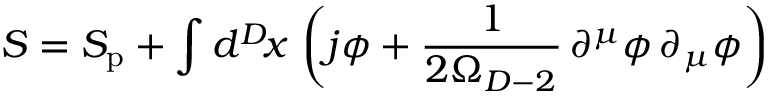Convert formula to latex. <formula><loc_0><loc_0><loc_500><loc_500>{ S } = S _ { p } + \int d ^ { D } \, x \, \left ( j \phi + \frac { 1 } { 2 \Omega _ { D - 2 } } \, \partial ^ { \mu } \phi \, \partial _ { \mu } \phi \right )</formula> 